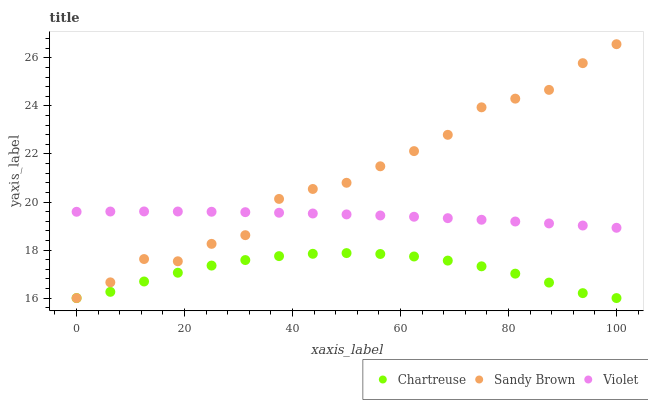Does Chartreuse have the minimum area under the curve?
Answer yes or no. Yes. Does Sandy Brown have the maximum area under the curve?
Answer yes or no. Yes. Does Violet have the minimum area under the curve?
Answer yes or no. No. Does Violet have the maximum area under the curve?
Answer yes or no. No. Is Violet the smoothest?
Answer yes or no. Yes. Is Sandy Brown the roughest?
Answer yes or no. Yes. Is Sandy Brown the smoothest?
Answer yes or no. No. Is Violet the roughest?
Answer yes or no. No. Does Chartreuse have the lowest value?
Answer yes or no. Yes. Does Violet have the lowest value?
Answer yes or no. No. Does Sandy Brown have the highest value?
Answer yes or no. Yes. Does Violet have the highest value?
Answer yes or no. No. Is Chartreuse less than Violet?
Answer yes or no. Yes. Is Violet greater than Chartreuse?
Answer yes or no. Yes. Does Sandy Brown intersect Chartreuse?
Answer yes or no. Yes. Is Sandy Brown less than Chartreuse?
Answer yes or no. No. Is Sandy Brown greater than Chartreuse?
Answer yes or no. No. Does Chartreuse intersect Violet?
Answer yes or no. No. 